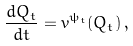Convert formula to latex. <formula><loc_0><loc_0><loc_500><loc_500>\frac { d Q _ { t } } { d t } = v ^ { \psi _ { t } } ( Q _ { t } ) \, ,</formula> 